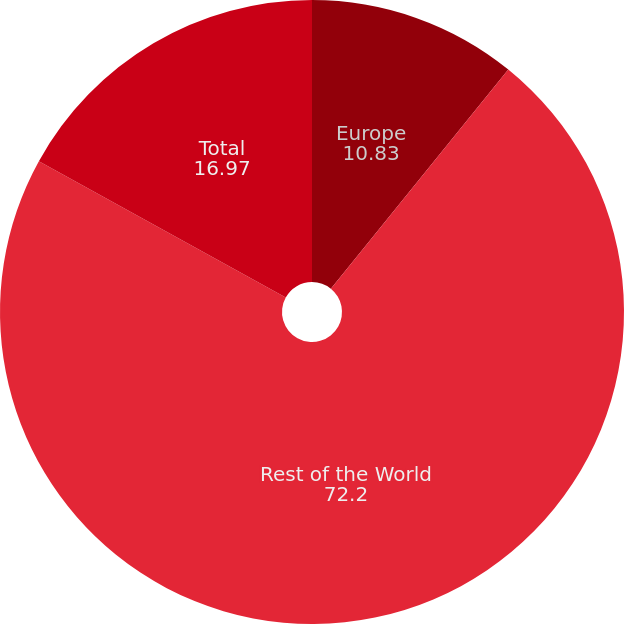Convert chart to OTSL. <chart><loc_0><loc_0><loc_500><loc_500><pie_chart><fcel>Europe<fcel>Rest of the World<fcel>Total<nl><fcel>10.83%<fcel>72.2%<fcel>16.97%<nl></chart> 